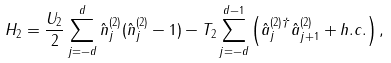<formula> <loc_0><loc_0><loc_500><loc_500>H _ { 2 } = \frac { U _ { 2 } } { 2 } \sum ^ { d } _ { j = - d } \hat { n } ^ { ( 2 ) } _ { j } ( \hat { n } ^ { ( 2 ) } _ { j } - 1 ) - T _ { 2 } \sum ^ { d - 1 } _ { j = - d } \left ( \hat { a } ^ { ( 2 ) \dagger } _ { j } \hat { a } ^ { ( 2 ) } _ { j + 1 } + h . c . \right ) ,</formula> 